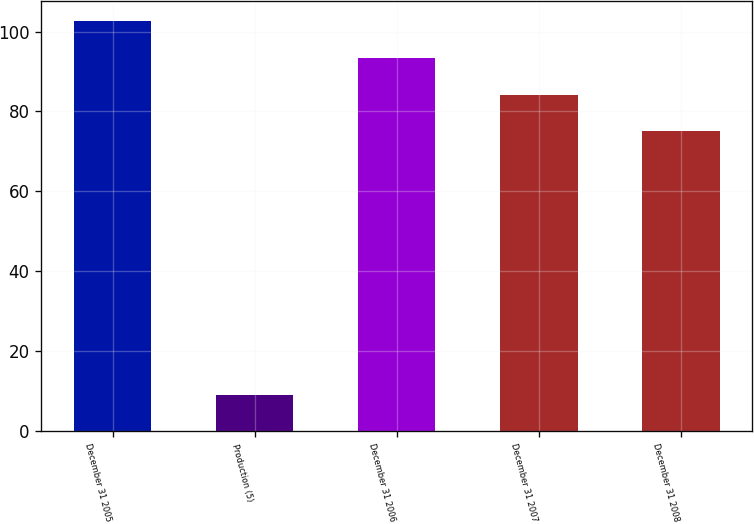Convert chart to OTSL. <chart><loc_0><loc_0><loc_500><loc_500><bar_chart><fcel>December 31 2005<fcel>Production (5)<fcel>December 31 2006<fcel>December 31 2007<fcel>December 31 2008<nl><fcel>102.6<fcel>9<fcel>93.4<fcel>84.2<fcel>75<nl></chart> 